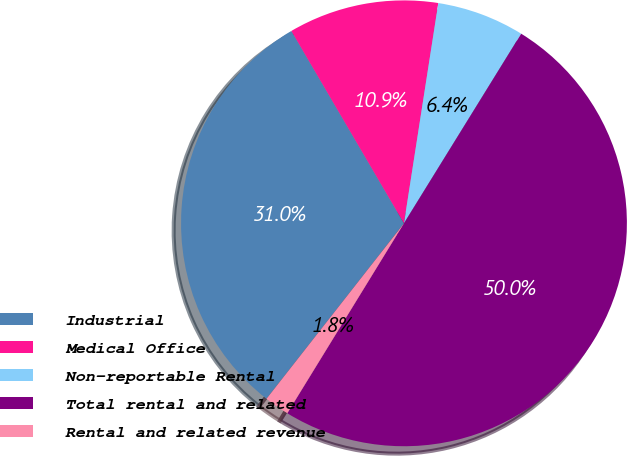<chart> <loc_0><loc_0><loc_500><loc_500><pie_chart><fcel>Industrial<fcel>Medical Office<fcel>Non-reportable Rental<fcel>Total rental and related<fcel>Rental and related revenue<nl><fcel>30.99%<fcel>10.89%<fcel>6.35%<fcel>49.95%<fcel>1.81%<nl></chart> 